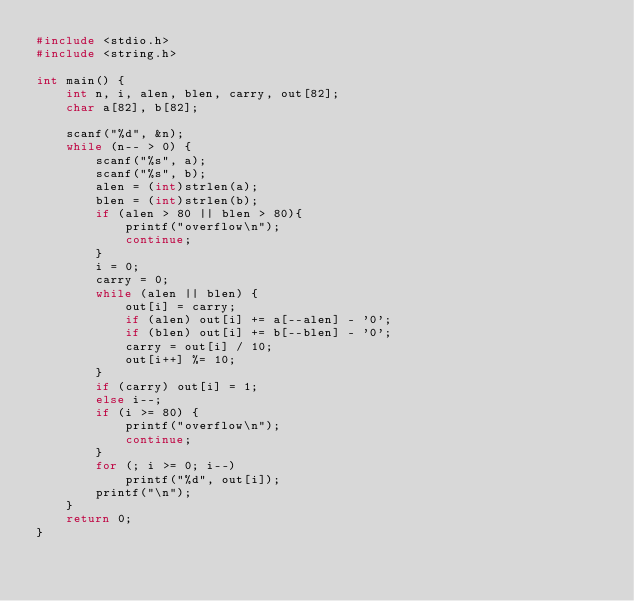<code> <loc_0><loc_0><loc_500><loc_500><_C_>#include <stdio.h>
#include <string.h>

int main() {
	int n, i, alen, blen, carry, out[82];
	char a[82], b[82];
	
	scanf("%d", &n);
	while (n-- > 0) {
		scanf("%s", a);
		scanf("%s", b);
		alen = (int)strlen(a);
		blen = (int)strlen(b);
		if (alen > 80 || blen > 80){
			printf("overflow\n");
			continue;
		}
		i = 0;
		carry = 0;
		while (alen || blen) {
			out[i] = carry;
			if (alen) out[i] += a[--alen] - '0';
			if (blen) out[i] += b[--blen] - '0';
			carry = out[i] / 10;
			out[i++] %= 10;
		}
		if (carry) out[i] = 1;
		else i--;
		if (i >= 80) {
			printf("overflow\n");
			continue;
		}
		for (; i >= 0; i--)
			printf("%d", out[i]);
		printf("\n");
	}
	return 0;
}</code> 